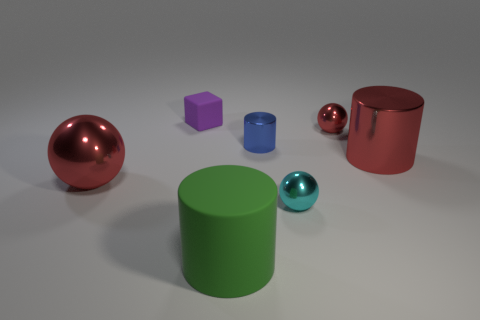Is there anything else that has the same shape as the purple object?
Make the answer very short. No. How many small objects are cylinders or cyan blocks?
Make the answer very short. 1. The thing that is in front of the purple rubber object and to the left of the big green matte cylinder has what shape?
Your response must be concise. Sphere. Does the blue cylinder have the same material as the tiny purple thing?
Your response must be concise. No. What color is the sphere that is the same size as the green rubber cylinder?
Provide a succinct answer. Red. What color is the cylinder that is in front of the small blue metallic cylinder and behind the big red shiny sphere?
Offer a terse response. Red. What size is the cylinder that is the same color as the big shiny sphere?
Keep it short and to the point. Large. What is the shape of the big object that is the same color as the large ball?
Offer a terse response. Cylinder. There is a matte object in front of the small object in front of the big thing that is left of the big green cylinder; how big is it?
Ensure brevity in your answer.  Large. What is the large green object made of?
Provide a succinct answer. Rubber. 